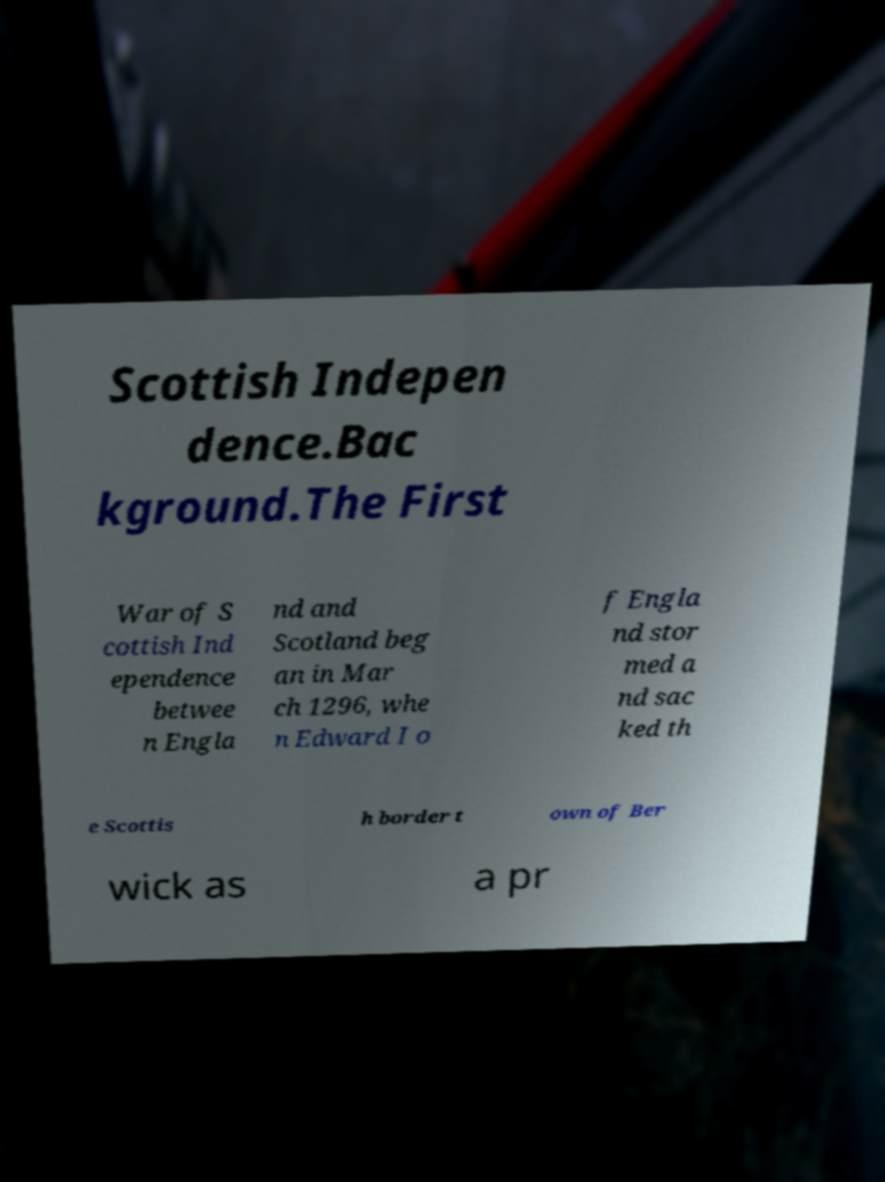Can you read and provide the text displayed in the image?This photo seems to have some interesting text. Can you extract and type it out for me? Scottish Indepen dence.Bac kground.The First War of S cottish Ind ependence betwee n Engla nd and Scotland beg an in Mar ch 1296, whe n Edward I o f Engla nd stor med a nd sac ked th e Scottis h border t own of Ber wick as a pr 